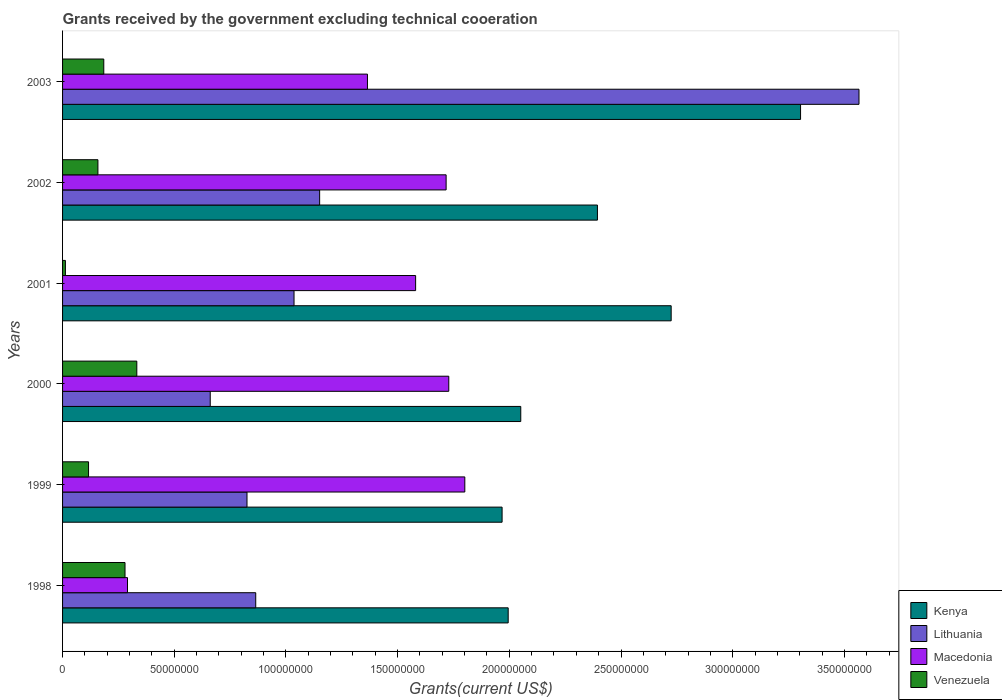How many groups of bars are there?
Provide a short and direct response. 6. Are the number of bars per tick equal to the number of legend labels?
Your response must be concise. Yes. Are the number of bars on each tick of the Y-axis equal?
Ensure brevity in your answer.  Yes. How many bars are there on the 3rd tick from the top?
Provide a succinct answer. 4. What is the total grants received by the government in Lithuania in 2002?
Give a very brief answer. 1.15e+08. Across all years, what is the maximum total grants received by the government in Macedonia?
Offer a very short reply. 1.80e+08. Across all years, what is the minimum total grants received by the government in Kenya?
Offer a terse response. 1.97e+08. In which year was the total grants received by the government in Venezuela minimum?
Offer a terse response. 2001. What is the total total grants received by the government in Macedonia in the graph?
Offer a very short reply. 8.48e+08. What is the difference between the total grants received by the government in Venezuela in 1999 and that in 2003?
Offer a terse response. -6.82e+06. What is the difference between the total grants received by the government in Venezuela in 2001 and the total grants received by the government in Lithuania in 2002?
Give a very brief answer. -1.14e+08. What is the average total grants received by the government in Macedonia per year?
Provide a short and direct response. 1.41e+08. In the year 2002, what is the difference between the total grants received by the government in Macedonia and total grants received by the government in Venezuela?
Provide a short and direct response. 1.56e+08. In how many years, is the total grants received by the government in Lithuania greater than 250000000 US$?
Your answer should be compact. 1. What is the ratio of the total grants received by the government in Macedonia in 1998 to that in 2001?
Your answer should be very brief. 0.18. Is the difference between the total grants received by the government in Macedonia in 2001 and 2003 greater than the difference between the total grants received by the government in Venezuela in 2001 and 2003?
Provide a short and direct response. Yes. What is the difference between the highest and the second highest total grants received by the government in Macedonia?
Provide a short and direct response. 7.18e+06. What is the difference between the highest and the lowest total grants received by the government in Lithuania?
Your answer should be very brief. 2.90e+08. In how many years, is the total grants received by the government in Macedonia greater than the average total grants received by the government in Macedonia taken over all years?
Keep it short and to the point. 4. What does the 2nd bar from the top in 2000 represents?
Ensure brevity in your answer.  Macedonia. What does the 3rd bar from the bottom in 1999 represents?
Ensure brevity in your answer.  Macedonia. Is it the case that in every year, the sum of the total grants received by the government in Lithuania and total grants received by the government in Kenya is greater than the total grants received by the government in Venezuela?
Ensure brevity in your answer.  Yes. How many bars are there?
Your answer should be compact. 24. What is the difference between two consecutive major ticks on the X-axis?
Keep it short and to the point. 5.00e+07. Where does the legend appear in the graph?
Give a very brief answer. Bottom right. How many legend labels are there?
Provide a short and direct response. 4. How are the legend labels stacked?
Provide a short and direct response. Vertical. What is the title of the graph?
Offer a terse response. Grants received by the government excluding technical cooeration. Does "East Asia (developing only)" appear as one of the legend labels in the graph?
Your response must be concise. No. What is the label or title of the X-axis?
Ensure brevity in your answer.  Grants(current US$). What is the Grants(current US$) in Kenya in 1998?
Offer a very short reply. 2.00e+08. What is the Grants(current US$) in Lithuania in 1998?
Offer a very short reply. 8.65e+07. What is the Grants(current US$) of Macedonia in 1998?
Give a very brief answer. 2.91e+07. What is the Grants(current US$) of Venezuela in 1998?
Offer a terse response. 2.80e+07. What is the Grants(current US$) of Kenya in 1999?
Your answer should be compact. 1.97e+08. What is the Grants(current US$) in Lithuania in 1999?
Your answer should be very brief. 8.26e+07. What is the Grants(current US$) of Macedonia in 1999?
Your answer should be compact. 1.80e+08. What is the Grants(current US$) in Venezuela in 1999?
Ensure brevity in your answer.  1.16e+07. What is the Grants(current US$) of Kenya in 2000?
Your answer should be very brief. 2.05e+08. What is the Grants(current US$) of Lithuania in 2000?
Your answer should be compact. 6.61e+07. What is the Grants(current US$) of Macedonia in 2000?
Your response must be concise. 1.73e+08. What is the Grants(current US$) of Venezuela in 2000?
Give a very brief answer. 3.32e+07. What is the Grants(current US$) in Kenya in 2001?
Ensure brevity in your answer.  2.72e+08. What is the Grants(current US$) in Lithuania in 2001?
Ensure brevity in your answer.  1.04e+08. What is the Grants(current US$) in Macedonia in 2001?
Your answer should be compact. 1.58e+08. What is the Grants(current US$) in Venezuela in 2001?
Provide a succinct answer. 1.27e+06. What is the Grants(current US$) in Kenya in 2002?
Ensure brevity in your answer.  2.39e+08. What is the Grants(current US$) of Lithuania in 2002?
Give a very brief answer. 1.15e+08. What is the Grants(current US$) in Macedonia in 2002?
Offer a terse response. 1.72e+08. What is the Grants(current US$) in Venezuela in 2002?
Give a very brief answer. 1.58e+07. What is the Grants(current US$) of Kenya in 2003?
Your response must be concise. 3.30e+08. What is the Grants(current US$) in Lithuania in 2003?
Your answer should be very brief. 3.57e+08. What is the Grants(current US$) in Macedonia in 2003?
Offer a very short reply. 1.36e+08. What is the Grants(current US$) in Venezuela in 2003?
Ensure brevity in your answer.  1.84e+07. Across all years, what is the maximum Grants(current US$) in Kenya?
Provide a short and direct response. 3.30e+08. Across all years, what is the maximum Grants(current US$) in Lithuania?
Your answer should be compact. 3.57e+08. Across all years, what is the maximum Grants(current US$) in Macedonia?
Your answer should be compact. 1.80e+08. Across all years, what is the maximum Grants(current US$) of Venezuela?
Your answer should be very brief. 3.32e+07. Across all years, what is the minimum Grants(current US$) in Kenya?
Your answer should be compact. 1.97e+08. Across all years, what is the minimum Grants(current US$) in Lithuania?
Your answer should be compact. 6.61e+07. Across all years, what is the minimum Grants(current US$) in Macedonia?
Provide a succinct answer. 2.91e+07. Across all years, what is the minimum Grants(current US$) of Venezuela?
Offer a very short reply. 1.27e+06. What is the total Grants(current US$) in Kenya in the graph?
Make the answer very short. 1.44e+09. What is the total Grants(current US$) in Lithuania in the graph?
Offer a terse response. 8.10e+08. What is the total Grants(current US$) of Macedonia in the graph?
Ensure brevity in your answer.  8.48e+08. What is the total Grants(current US$) of Venezuela in the graph?
Offer a terse response. 1.08e+08. What is the difference between the Grants(current US$) of Kenya in 1998 and that in 1999?
Provide a succinct answer. 2.73e+06. What is the difference between the Grants(current US$) of Lithuania in 1998 and that in 1999?
Offer a very short reply. 3.91e+06. What is the difference between the Grants(current US$) of Macedonia in 1998 and that in 1999?
Your answer should be very brief. -1.51e+08. What is the difference between the Grants(current US$) of Venezuela in 1998 and that in 1999?
Your answer should be very brief. 1.63e+07. What is the difference between the Grants(current US$) of Kenya in 1998 and that in 2000?
Ensure brevity in your answer.  -5.63e+06. What is the difference between the Grants(current US$) in Lithuania in 1998 and that in 2000?
Your answer should be very brief. 2.04e+07. What is the difference between the Grants(current US$) of Macedonia in 1998 and that in 2000?
Give a very brief answer. -1.44e+08. What is the difference between the Grants(current US$) of Venezuela in 1998 and that in 2000?
Make the answer very short. -5.28e+06. What is the difference between the Grants(current US$) in Kenya in 1998 and that in 2001?
Your response must be concise. -7.30e+07. What is the difference between the Grants(current US$) in Lithuania in 1998 and that in 2001?
Provide a succinct answer. -1.71e+07. What is the difference between the Grants(current US$) in Macedonia in 1998 and that in 2001?
Your answer should be compact. -1.29e+08. What is the difference between the Grants(current US$) in Venezuela in 1998 and that in 2001?
Your answer should be very brief. 2.67e+07. What is the difference between the Grants(current US$) of Kenya in 1998 and that in 2002?
Your answer should be compact. -4.00e+07. What is the difference between the Grants(current US$) in Lithuania in 1998 and that in 2002?
Ensure brevity in your answer.  -2.86e+07. What is the difference between the Grants(current US$) of Macedonia in 1998 and that in 2002?
Keep it short and to the point. -1.43e+08. What is the difference between the Grants(current US$) of Venezuela in 1998 and that in 2002?
Ensure brevity in your answer.  1.21e+07. What is the difference between the Grants(current US$) in Kenya in 1998 and that in 2003?
Your answer should be very brief. -1.31e+08. What is the difference between the Grants(current US$) in Lithuania in 1998 and that in 2003?
Provide a succinct answer. -2.70e+08. What is the difference between the Grants(current US$) in Macedonia in 1998 and that in 2003?
Make the answer very short. -1.07e+08. What is the difference between the Grants(current US$) in Venezuela in 1998 and that in 2003?
Your response must be concise. 9.51e+06. What is the difference between the Grants(current US$) in Kenya in 1999 and that in 2000?
Keep it short and to the point. -8.36e+06. What is the difference between the Grants(current US$) of Lithuania in 1999 and that in 2000?
Keep it short and to the point. 1.65e+07. What is the difference between the Grants(current US$) in Macedonia in 1999 and that in 2000?
Offer a very short reply. 7.18e+06. What is the difference between the Grants(current US$) of Venezuela in 1999 and that in 2000?
Ensure brevity in your answer.  -2.16e+07. What is the difference between the Grants(current US$) of Kenya in 1999 and that in 2001?
Provide a short and direct response. -7.57e+07. What is the difference between the Grants(current US$) of Lithuania in 1999 and that in 2001?
Your answer should be very brief. -2.10e+07. What is the difference between the Grants(current US$) in Macedonia in 1999 and that in 2001?
Ensure brevity in your answer.  2.20e+07. What is the difference between the Grants(current US$) of Venezuela in 1999 and that in 2001?
Keep it short and to the point. 1.04e+07. What is the difference between the Grants(current US$) in Kenya in 1999 and that in 2002?
Provide a short and direct response. -4.27e+07. What is the difference between the Grants(current US$) in Lithuania in 1999 and that in 2002?
Offer a very short reply. -3.25e+07. What is the difference between the Grants(current US$) of Macedonia in 1999 and that in 2002?
Offer a very short reply. 8.37e+06. What is the difference between the Grants(current US$) in Venezuela in 1999 and that in 2002?
Give a very brief answer. -4.20e+06. What is the difference between the Grants(current US$) in Kenya in 1999 and that in 2003?
Give a very brief answer. -1.34e+08. What is the difference between the Grants(current US$) of Lithuania in 1999 and that in 2003?
Ensure brevity in your answer.  -2.74e+08. What is the difference between the Grants(current US$) in Macedonia in 1999 and that in 2003?
Provide a short and direct response. 4.36e+07. What is the difference between the Grants(current US$) in Venezuela in 1999 and that in 2003?
Make the answer very short. -6.82e+06. What is the difference between the Grants(current US$) in Kenya in 2000 and that in 2001?
Make the answer very short. -6.73e+07. What is the difference between the Grants(current US$) of Lithuania in 2000 and that in 2001?
Keep it short and to the point. -3.75e+07. What is the difference between the Grants(current US$) in Macedonia in 2000 and that in 2001?
Your answer should be compact. 1.48e+07. What is the difference between the Grants(current US$) in Venezuela in 2000 and that in 2001?
Ensure brevity in your answer.  3.20e+07. What is the difference between the Grants(current US$) of Kenya in 2000 and that in 2002?
Your response must be concise. -3.43e+07. What is the difference between the Grants(current US$) of Lithuania in 2000 and that in 2002?
Your answer should be compact. -4.90e+07. What is the difference between the Grants(current US$) in Macedonia in 2000 and that in 2002?
Give a very brief answer. 1.19e+06. What is the difference between the Grants(current US$) of Venezuela in 2000 and that in 2002?
Ensure brevity in your answer.  1.74e+07. What is the difference between the Grants(current US$) in Kenya in 2000 and that in 2003?
Provide a short and direct response. -1.25e+08. What is the difference between the Grants(current US$) of Lithuania in 2000 and that in 2003?
Your answer should be very brief. -2.90e+08. What is the difference between the Grants(current US$) of Macedonia in 2000 and that in 2003?
Give a very brief answer. 3.64e+07. What is the difference between the Grants(current US$) of Venezuela in 2000 and that in 2003?
Ensure brevity in your answer.  1.48e+07. What is the difference between the Grants(current US$) in Kenya in 2001 and that in 2002?
Offer a terse response. 3.30e+07. What is the difference between the Grants(current US$) of Lithuania in 2001 and that in 2002?
Offer a terse response. -1.15e+07. What is the difference between the Grants(current US$) in Macedonia in 2001 and that in 2002?
Offer a terse response. -1.36e+07. What is the difference between the Grants(current US$) in Venezuela in 2001 and that in 2002?
Your response must be concise. -1.46e+07. What is the difference between the Grants(current US$) in Kenya in 2001 and that in 2003?
Make the answer very short. -5.79e+07. What is the difference between the Grants(current US$) of Lithuania in 2001 and that in 2003?
Offer a terse response. -2.53e+08. What is the difference between the Grants(current US$) in Macedonia in 2001 and that in 2003?
Your answer should be compact. 2.16e+07. What is the difference between the Grants(current US$) in Venezuela in 2001 and that in 2003?
Provide a succinct answer. -1.72e+07. What is the difference between the Grants(current US$) of Kenya in 2002 and that in 2003?
Your answer should be very brief. -9.09e+07. What is the difference between the Grants(current US$) in Lithuania in 2002 and that in 2003?
Provide a short and direct response. -2.41e+08. What is the difference between the Grants(current US$) in Macedonia in 2002 and that in 2003?
Give a very brief answer. 3.52e+07. What is the difference between the Grants(current US$) in Venezuela in 2002 and that in 2003?
Provide a short and direct response. -2.62e+06. What is the difference between the Grants(current US$) of Kenya in 1998 and the Grants(current US$) of Lithuania in 1999?
Your answer should be compact. 1.17e+08. What is the difference between the Grants(current US$) of Kenya in 1998 and the Grants(current US$) of Macedonia in 1999?
Ensure brevity in your answer.  1.94e+07. What is the difference between the Grants(current US$) of Kenya in 1998 and the Grants(current US$) of Venezuela in 1999?
Your answer should be compact. 1.88e+08. What is the difference between the Grants(current US$) in Lithuania in 1998 and the Grants(current US$) in Macedonia in 1999?
Your answer should be compact. -9.36e+07. What is the difference between the Grants(current US$) of Lithuania in 1998 and the Grants(current US$) of Venezuela in 1999?
Your response must be concise. 7.48e+07. What is the difference between the Grants(current US$) in Macedonia in 1998 and the Grants(current US$) in Venezuela in 1999?
Ensure brevity in your answer.  1.74e+07. What is the difference between the Grants(current US$) of Kenya in 1998 and the Grants(current US$) of Lithuania in 2000?
Your response must be concise. 1.33e+08. What is the difference between the Grants(current US$) of Kenya in 1998 and the Grants(current US$) of Macedonia in 2000?
Give a very brief answer. 2.66e+07. What is the difference between the Grants(current US$) in Kenya in 1998 and the Grants(current US$) in Venezuela in 2000?
Provide a succinct answer. 1.66e+08. What is the difference between the Grants(current US$) in Lithuania in 1998 and the Grants(current US$) in Macedonia in 2000?
Ensure brevity in your answer.  -8.64e+07. What is the difference between the Grants(current US$) in Lithuania in 1998 and the Grants(current US$) in Venezuela in 2000?
Your answer should be compact. 5.32e+07. What is the difference between the Grants(current US$) in Macedonia in 1998 and the Grants(current US$) in Venezuela in 2000?
Your response must be concise. -4.17e+06. What is the difference between the Grants(current US$) in Kenya in 1998 and the Grants(current US$) in Lithuania in 2001?
Offer a terse response. 9.59e+07. What is the difference between the Grants(current US$) in Kenya in 1998 and the Grants(current US$) in Macedonia in 2001?
Provide a short and direct response. 4.14e+07. What is the difference between the Grants(current US$) of Kenya in 1998 and the Grants(current US$) of Venezuela in 2001?
Keep it short and to the point. 1.98e+08. What is the difference between the Grants(current US$) of Lithuania in 1998 and the Grants(current US$) of Macedonia in 2001?
Your response must be concise. -7.16e+07. What is the difference between the Grants(current US$) in Lithuania in 1998 and the Grants(current US$) in Venezuela in 2001?
Give a very brief answer. 8.52e+07. What is the difference between the Grants(current US$) of Macedonia in 1998 and the Grants(current US$) of Venezuela in 2001?
Ensure brevity in your answer.  2.78e+07. What is the difference between the Grants(current US$) of Kenya in 1998 and the Grants(current US$) of Lithuania in 2002?
Your answer should be very brief. 8.44e+07. What is the difference between the Grants(current US$) of Kenya in 1998 and the Grants(current US$) of Macedonia in 2002?
Give a very brief answer. 2.78e+07. What is the difference between the Grants(current US$) of Kenya in 1998 and the Grants(current US$) of Venezuela in 2002?
Provide a succinct answer. 1.84e+08. What is the difference between the Grants(current US$) in Lithuania in 1998 and the Grants(current US$) in Macedonia in 2002?
Your answer should be very brief. -8.52e+07. What is the difference between the Grants(current US$) of Lithuania in 1998 and the Grants(current US$) of Venezuela in 2002?
Provide a succinct answer. 7.06e+07. What is the difference between the Grants(current US$) in Macedonia in 1998 and the Grants(current US$) in Venezuela in 2002?
Provide a short and direct response. 1.32e+07. What is the difference between the Grants(current US$) of Kenya in 1998 and the Grants(current US$) of Lithuania in 2003?
Ensure brevity in your answer.  -1.57e+08. What is the difference between the Grants(current US$) in Kenya in 1998 and the Grants(current US$) in Macedonia in 2003?
Your response must be concise. 6.30e+07. What is the difference between the Grants(current US$) in Kenya in 1998 and the Grants(current US$) in Venezuela in 2003?
Provide a short and direct response. 1.81e+08. What is the difference between the Grants(current US$) of Lithuania in 1998 and the Grants(current US$) of Macedonia in 2003?
Offer a terse response. -5.00e+07. What is the difference between the Grants(current US$) in Lithuania in 1998 and the Grants(current US$) in Venezuela in 2003?
Offer a terse response. 6.80e+07. What is the difference between the Grants(current US$) of Macedonia in 1998 and the Grants(current US$) of Venezuela in 2003?
Keep it short and to the point. 1.06e+07. What is the difference between the Grants(current US$) in Kenya in 1999 and the Grants(current US$) in Lithuania in 2000?
Your answer should be very brief. 1.31e+08. What is the difference between the Grants(current US$) of Kenya in 1999 and the Grants(current US$) of Macedonia in 2000?
Your response must be concise. 2.39e+07. What is the difference between the Grants(current US$) of Kenya in 1999 and the Grants(current US$) of Venezuela in 2000?
Give a very brief answer. 1.64e+08. What is the difference between the Grants(current US$) in Lithuania in 1999 and the Grants(current US$) in Macedonia in 2000?
Make the answer very short. -9.03e+07. What is the difference between the Grants(current US$) in Lithuania in 1999 and the Grants(current US$) in Venezuela in 2000?
Keep it short and to the point. 4.93e+07. What is the difference between the Grants(current US$) of Macedonia in 1999 and the Grants(current US$) of Venezuela in 2000?
Offer a very short reply. 1.47e+08. What is the difference between the Grants(current US$) in Kenya in 1999 and the Grants(current US$) in Lithuania in 2001?
Make the answer very short. 9.32e+07. What is the difference between the Grants(current US$) in Kenya in 1999 and the Grants(current US$) in Macedonia in 2001?
Your answer should be very brief. 3.87e+07. What is the difference between the Grants(current US$) in Kenya in 1999 and the Grants(current US$) in Venezuela in 2001?
Your response must be concise. 1.96e+08. What is the difference between the Grants(current US$) in Lithuania in 1999 and the Grants(current US$) in Macedonia in 2001?
Your answer should be compact. -7.55e+07. What is the difference between the Grants(current US$) in Lithuania in 1999 and the Grants(current US$) in Venezuela in 2001?
Ensure brevity in your answer.  8.13e+07. What is the difference between the Grants(current US$) in Macedonia in 1999 and the Grants(current US$) in Venezuela in 2001?
Provide a short and direct response. 1.79e+08. What is the difference between the Grants(current US$) of Kenya in 1999 and the Grants(current US$) of Lithuania in 2002?
Offer a very short reply. 8.17e+07. What is the difference between the Grants(current US$) in Kenya in 1999 and the Grants(current US$) in Macedonia in 2002?
Make the answer very short. 2.51e+07. What is the difference between the Grants(current US$) of Kenya in 1999 and the Grants(current US$) of Venezuela in 2002?
Provide a short and direct response. 1.81e+08. What is the difference between the Grants(current US$) in Lithuania in 1999 and the Grants(current US$) in Macedonia in 2002?
Offer a terse response. -8.91e+07. What is the difference between the Grants(current US$) in Lithuania in 1999 and the Grants(current US$) in Venezuela in 2002?
Your answer should be compact. 6.67e+07. What is the difference between the Grants(current US$) of Macedonia in 1999 and the Grants(current US$) of Venezuela in 2002?
Keep it short and to the point. 1.64e+08. What is the difference between the Grants(current US$) in Kenya in 1999 and the Grants(current US$) in Lithuania in 2003?
Provide a succinct answer. -1.60e+08. What is the difference between the Grants(current US$) of Kenya in 1999 and the Grants(current US$) of Macedonia in 2003?
Keep it short and to the point. 6.03e+07. What is the difference between the Grants(current US$) of Kenya in 1999 and the Grants(current US$) of Venezuela in 2003?
Your response must be concise. 1.78e+08. What is the difference between the Grants(current US$) in Lithuania in 1999 and the Grants(current US$) in Macedonia in 2003?
Your answer should be compact. -5.39e+07. What is the difference between the Grants(current US$) in Lithuania in 1999 and the Grants(current US$) in Venezuela in 2003?
Your answer should be very brief. 6.41e+07. What is the difference between the Grants(current US$) in Macedonia in 1999 and the Grants(current US$) in Venezuela in 2003?
Your answer should be compact. 1.62e+08. What is the difference between the Grants(current US$) of Kenya in 2000 and the Grants(current US$) of Lithuania in 2001?
Your answer should be compact. 1.02e+08. What is the difference between the Grants(current US$) of Kenya in 2000 and the Grants(current US$) of Macedonia in 2001?
Provide a succinct answer. 4.71e+07. What is the difference between the Grants(current US$) in Kenya in 2000 and the Grants(current US$) in Venezuela in 2001?
Your answer should be very brief. 2.04e+08. What is the difference between the Grants(current US$) of Lithuania in 2000 and the Grants(current US$) of Macedonia in 2001?
Your answer should be compact. -9.20e+07. What is the difference between the Grants(current US$) in Lithuania in 2000 and the Grants(current US$) in Venezuela in 2001?
Your answer should be very brief. 6.48e+07. What is the difference between the Grants(current US$) of Macedonia in 2000 and the Grants(current US$) of Venezuela in 2001?
Make the answer very short. 1.72e+08. What is the difference between the Grants(current US$) in Kenya in 2000 and the Grants(current US$) in Lithuania in 2002?
Your answer should be very brief. 9.00e+07. What is the difference between the Grants(current US$) of Kenya in 2000 and the Grants(current US$) of Macedonia in 2002?
Offer a very short reply. 3.34e+07. What is the difference between the Grants(current US$) in Kenya in 2000 and the Grants(current US$) in Venezuela in 2002?
Provide a short and direct response. 1.89e+08. What is the difference between the Grants(current US$) of Lithuania in 2000 and the Grants(current US$) of Macedonia in 2002?
Your answer should be compact. -1.06e+08. What is the difference between the Grants(current US$) of Lithuania in 2000 and the Grants(current US$) of Venezuela in 2002?
Provide a short and direct response. 5.03e+07. What is the difference between the Grants(current US$) of Macedonia in 2000 and the Grants(current US$) of Venezuela in 2002?
Provide a short and direct response. 1.57e+08. What is the difference between the Grants(current US$) in Kenya in 2000 and the Grants(current US$) in Lithuania in 2003?
Your answer should be compact. -1.51e+08. What is the difference between the Grants(current US$) of Kenya in 2000 and the Grants(current US$) of Macedonia in 2003?
Provide a succinct answer. 6.86e+07. What is the difference between the Grants(current US$) of Kenya in 2000 and the Grants(current US$) of Venezuela in 2003?
Your response must be concise. 1.87e+08. What is the difference between the Grants(current US$) in Lithuania in 2000 and the Grants(current US$) in Macedonia in 2003?
Make the answer very short. -7.04e+07. What is the difference between the Grants(current US$) in Lithuania in 2000 and the Grants(current US$) in Venezuela in 2003?
Provide a short and direct response. 4.77e+07. What is the difference between the Grants(current US$) of Macedonia in 2000 and the Grants(current US$) of Venezuela in 2003?
Offer a terse response. 1.54e+08. What is the difference between the Grants(current US$) of Kenya in 2001 and the Grants(current US$) of Lithuania in 2002?
Your answer should be very brief. 1.57e+08. What is the difference between the Grants(current US$) of Kenya in 2001 and the Grants(current US$) of Macedonia in 2002?
Keep it short and to the point. 1.01e+08. What is the difference between the Grants(current US$) in Kenya in 2001 and the Grants(current US$) in Venezuela in 2002?
Provide a succinct answer. 2.57e+08. What is the difference between the Grants(current US$) of Lithuania in 2001 and the Grants(current US$) of Macedonia in 2002?
Your answer should be very brief. -6.81e+07. What is the difference between the Grants(current US$) of Lithuania in 2001 and the Grants(current US$) of Venezuela in 2002?
Ensure brevity in your answer.  8.78e+07. What is the difference between the Grants(current US$) in Macedonia in 2001 and the Grants(current US$) in Venezuela in 2002?
Provide a succinct answer. 1.42e+08. What is the difference between the Grants(current US$) in Kenya in 2001 and the Grants(current US$) in Lithuania in 2003?
Your response must be concise. -8.41e+07. What is the difference between the Grants(current US$) of Kenya in 2001 and the Grants(current US$) of Macedonia in 2003?
Your response must be concise. 1.36e+08. What is the difference between the Grants(current US$) of Kenya in 2001 and the Grants(current US$) of Venezuela in 2003?
Your response must be concise. 2.54e+08. What is the difference between the Grants(current US$) in Lithuania in 2001 and the Grants(current US$) in Macedonia in 2003?
Keep it short and to the point. -3.29e+07. What is the difference between the Grants(current US$) in Lithuania in 2001 and the Grants(current US$) in Venezuela in 2003?
Offer a terse response. 8.52e+07. What is the difference between the Grants(current US$) of Macedonia in 2001 and the Grants(current US$) of Venezuela in 2003?
Your answer should be very brief. 1.40e+08. What is the difference between the Grants(current US$) of Kenya in 2002 and the Grants(current US$) of Lithuania in 2003?
Give a very brief answer. -1.17e+08. What is the difference between the Grants(current US$) of Kenya in 2002 and the Grants(current US$) of Macedonia in 2003?
Your answer should be very brief. 1.03e+08. What is the difference between the Grants(current US$) in Kenya in 2002 and the Grants(current US$) in Venezuela in 2003?
Provide a succinct answer. 2.21e+08. What is the difference between the Grants(current US$) in Lithuania in 2002 and the Grants(current US$) in Macedonia in 2003?
Ensure brevity in your answer.  -2.14e+07. What is the difference between the Grants(current US$) in Lithuania in 2002 and the Grants(current US$) in Venezuela in 2003?
Provide a short and direct response. 9.66e+07. What is the difference between the Grants(current US$) in Macedonia in 2002 and the Grants(current US$) in Venezuela in 2003?
Provide a short and direct response. 1.53e+08. What is the average Grants(current US$) in Kenya per year?
Ensure brevity in your answer.  2.41e+08. What is the average Grants(current US$) of Lithuania per year?
Your response must be concise. 1.35e+08. What is the average Grants(current US$) in Macedonia per year?
Your response must be concise. 1.41e+08. What is the average Grants(current US$) in Venezuela per year?
Your answer should be compact. 1.81e+07. In the year 1998, what is the difference between the Grants(current US$) in Kenya and Grants(current US$) in Lithuania?
Offer a terse response. 1.13e+08. In the year 1998, what is the difference between the Grants(current US$) in Kenya and Grants(current US$) in Macedonia?
Offer a very short reply. 1.70e+08. In the year 1998, what is the difference between the Grants(current US$) of Kenya and Grants(current US$) of Venezuela?
Your answer should be very brief. 1.72e+08. In the year 1998, what is the difference between the Grants(current US$) of Lithuania and Grants(current US$) of Macedonia?
Ensure brevity in your answer.  5.74e+07. In the year 1998, what is the difference between the Grants(current US$) in Lithuania and Grants(current US$) in Venezuela?
Make the answer very short. 5.85e+07. In the year 1998, what is the difference between the Grants(current US$) in Macedonia and Grants(current US$) in Venezuela?
Your response must be concise. 1.11e+06. In the year 1999, what is the difference between the Grants(current US$) in Kenya and Grants(current US$) in Lithuania?
Ensure brevity in your answer.  1.14e+08. In the year 1999, what is the difference between the Grants(current US$) of Kenya and Grants(current US$) of Macedonia?
Offer a terse response. 1.67e+07. In the year 1999, what is the difference between the Grants(current US$) of Kenya and Grants(current US$) of Venezuela?
Your response must be concise. 1.85e+08. In the year 1999, what is the difference between the Grants(current US$) of Lithuania and Grants(current US$) of Macedonia?
Your answer should be compact. -9.75e+07. In the year 1999, what is the difference between the Grants(current US$) of Lithuania and Grants(current US$) of Venezuela?
Make the answer very short. 7.09e+07. In the year 1999, what is the difference between the Grants(current US$) in Macedonia and Grants(current US$) in Venezuela?
Your response must be concise. 1.68e+08. In the year 2000, what is the difference between the Grants(current US$) in Kenya and Grants(current US$) in Lithuania?
Provide a succinct answer. 1.39e+08. In the year 2000, what is the difference between the Grants(current US$) in Kenya and Grants(current US$) in Macedonia?
Your answer should be very brief. 3.22e+07. In the year 2000, what is the difference between the Grants(current US$) of Kenya and Grants(current US$) of Venezuela?
Give a very brief answer. 1.72e+08. In the year 2000, what is the difference between the Grants(current US$) in Lithuania and Grants(current US$) in Macedonia?
Ensure brevity in your answer.  -1.07e+08. In the year 2000, what is the difference between the Grants(current US$) of Lithuania and Grants(current US$) of Venezuela?
Provide a succinct answer. 3.29e+07. In the year 2000, what is the difference between the Grants(current US$) of Macedonia and Grants(current US$) of Venezuela?
Make the answer very short. 1.40e+08. In the year 2001, what is the difference between the Grants(current US$) of Kenya and Grants(current US$) of Lithuania?
Make the answer very short. 1.69e+08. In the year 2001, what is the difference between the Grants(current US$) in Kenya and Grants(current US$) in Macedonia?
Offer a terse response. 1.14e+08. In the year 2001, what is the difference between the Grants(current US$) in Kenya and Grants(current US$) in Venezuela?
Your answer should be very brief. 2.71e+08. In the year 2001, what is the difference between the Grants(current US$) in Lithuania and Grants(current US$) in Macedonia?
Offer a very short reply. -5.44e+07. In the year 2001, what is the difference between the Grants(current US$) in Lithuania and Grants(current US$) in Venezuela?
Ensure brevity in your answer.  1.02e+08. In the year 2001, what is the difference between the Grants(current US$) in Macedonia and Grants(current US$) in Venezuela?
Ensure brevity in your answer.  1.57e+08. In the year 2002, what is the difference between the Grants(current US$) of Kenya and Grants(current US$) of Lithuania?
Provide a succinct answer. 1.24e+08. In the year 2002, what is the difference between the Grants(current US$) in Kenya and Grants(current US$) in Macedonia?
Your answer should be compact. 6.77e+07. In the year 2002, what is the difference between the Grants(current US$) in Kenya and Grants(current US$) in Venezuela?
Ensure brevity in your answer.  2.24e+08. In the year 2002, what is the difference between the Grants(current US$) in Lithuania and Grants(current US$) in Macedonia?
Offer a very short reply. -5.66e+07. In the year 2002, what is the difference between the Grants(current US$) of Lithuania and Grants(current US$) of Venezuela?
Ensure brevity in your answer.  9.93e+07. In the year 2002, what is the difference between the Grants(current US$) in Macedonia and Grants(current US$) in Venezuela?
Your answer should be compact. 1.56e+08. In the year 2003, what is the difference between the Grants(current US$) of Kenya and Grants(current US$) of Lithuania?
Give a very brief answer. -2.62e+07. In the year 2003, what is the difference between the Grants(current US$) of Kenya and Grants(current US$) of Macedonia?
Ensure brevity in your answer.  1.94e+08. In the year 2003, what is the difference between the Grants(current US$) in Kenya and Grants(current US$) in Venezuela?
Your answer should be very brief. 3.12e+08. In the year 2003, what is the difference between the Grants(current US$) of Lithuania and Grants(current US$) of Macedonia?
Make the answer very short. 2.20e+08. In the year 2003, what is the difference between the Grants(current US$) in Lithuania and Grants(current US$) in Venezuela?
Ensure brevity in your answer.  3.38e+08. In the year 2003, what is the difference between the Grants(current US$) of Macedonia and Grants(current US$) of Venezuela?
Offer a terse response. 1.18e+08. What is the ratio of the Grants(current US$) of Kenya in 1998 to that in 1999?
Make the answer very short. 1.01. What is the ratio of the Grants(current US$) in Lithuania in 1998 to that in 1999?
Provide a succinct answer. 1.05. What is the ratio of the Grants(current US$) of Macedonia in 1998 to that in 1999?
Keep it short and to the point. 0.16. What is the ratio of the Grants(current US$) of Venezuela in 1998 to that in 1999?
Offer a terse response. 2.4. What is the ratio of the Grants(current US$) of Kenya in 1998 to that in 2000?
Keep it short and to the point. 0.97. What is the ratio of the Grants(current US$) of Lithuania in 1998 to that in 2000?
Your answer should be compact. 1.31. What is the ratio of the Grants(current US$) in Macedonia in 1998 to that in 2000?
Offer a terse response. 0.17. What is the ratio of the Grants(current US$) in Venezuela in 1998 to that in 2000?
Offer a terse response. 0.84. What is the ratio of the Grants(current US$) in Kenya in 1998 to that in 2001?
Ensure brevity in your answer.  0.73. What is the ratio of the Grants(current US$) in Lithuania in 1998 to that in 2001?
Give a very brief answer. 0.83. What is the ratio of the Grants(current US$) in Macedonia in 1998 to that in 2001?
Offer a terse response. 0.18. What is the ratio of the Grants(current US$) of Venezuela in 1998 to that in 2001?
Keep it short and to the point. 22.02. What is the ratio of the Grants(current US$) in Kenya in 1998 to that in 2002?
Ensure brevity in your answer.  0.83. What is the ratio of the Grants(current US$) of Lithuania in 1998 to that in 2002?
Your answer should be compact. 0.75. What is the ratio of the Grants(current US$) of Macedonia in 1998 to that in 2002?
Give a very brief answer. 0.17. What is the ratio of the Grants(current US$) in Venezuela in 1998 to that in 2002?
Provide a succinct answer. 1.77. What is the ratio of the Grants(current US$) of Kenya in 1998 to that in 2003?
Provide a succinct answer. 0.6. What is the ratio of the Grants(current US$) in Lithuania in 1998 to that in 2003?
Keep it short and to the point. 0.24. What is the ratio of the Grants(current US$) of Macedonia in 1998 to that in 2003?
Make the answer very short. 0.21. What is the ratio of the Grants(current US$) in Venezuela in 1998 to that in 2003?
Ensure brevity in your answer.  1.52. What is the ratio of the Grants(current US$) of Kenya in 1999 to that in 2000?
Your response must be concise. 0.96. What is the ratio of the Grants(current US$) of Lithuania in 1999 to that in 2000?
Provide a short and direct response. 1.25. What is the ratio of the Grants(current US$) of Macedonia in 1999 to that in 2000?
Provide a short and direct response. 1.04. What is the ratio of the Grants(current US$) of Venezuela in 1999 to that in 2000?
Keep it short and to the point. 0.35. What is the ratio of the Grants(current US$) in Kenya in 1999 to that in 2001?
Offer a terse response. 0.72. What is the ratio of the Grants(current US$) of Lithuania in 1999 to that in 2001?
Ensure brevity in your answer.  0.8. What is the ratio of the Grants(current US$) of Macedonia in 1999 to that in 2001?
Ensure brevity in your answer.  1.14. What is the ratio of the Grants(current US$) of Venezuela in 1999 to that in 2001?
Provide a short and direct response. 9.16. What is the ratio of the Grants(current US$) of Kenya in 1999 to that in 2002?
Your answer should be very brief. 0.82. What is the ratio of the Grants(current US$) in Lithuania in 1999 to that in 2002?
Your response must be concise. 0.72. What is the ratio of the Grants(current US$) in Macedonia in 1999 to that in 2002?
Ensure brevity in your answer.  1.05. What is the ratio of the Grants(current US$) of Venezuela in 1999 to that in 2002?
Your answer should be very brief. 0.73. What is the ratio of the Grants(current US$) of Kenya in 1999 to that in 2003?
Offer a very short reply. 0.6. What is the ratio of the Grants(current US$) in Lithuania in 1999 to that in 2003?
Provide a short and direct response. 0.23. What is the ratio of the Grants(current US$) of Macedonia in 1999 to that in 2003?
Offer a terse response. 1.32. What is the ratio of the Grants(current US$) of Venezuela in 1999 to that in 2003?
Offer a terse response. 0.63. What is the ratio of the Grants(current US$) of Kenya in 2000 to that in 2001?
Ensure brevity in your answer.  0.75. What is the ratio of the Grants(current US$) in Lithuania in 2000 to that in 2001?
Your answer should be very brief. 0.64. What is the ratio of the Grants(current US$) of Macedonia in 2000 to that in 2001?
Ensure brevity in your answer.  1.09. What is the ratio of the Grants(current US$) in Venezuela in 2000 to that in 2001?
Ensure brevity in your answer.  26.17. What is the ratio of the Grants(current US$) of Kenya in 2000 to that in 2002?
Make the answer very short. 0.86. What is the ratio of the Grants(current US$) of Lithuania in 2000 to that in 2002?
Offer a very short reply. 0.57. What is the ratio of the Grants(current US$) of Macedonia in 2000 to that in 2002?
Your answer should be very brief. 1.01. What is the ratio of the Grants(current US$) of Venezuela in 2000 to that in 2002?
Offer a terse response. 2.1. What is the ratio of the Grants(current US$) of Kenya in 2000 to that in 2003?
Your answer should be very brief. 0.62. What is the ratio of the Grants(current US$) of Lithuania in 2000 to that in 2003?
Ensure brevity in your answer.  0.19. What is the ratio of the Grants(current US$) of Macedonia in 2000 to that in 2003?
Your answer should be compact. 1.27. What is the ratio of the Grants(current US$) of Venezuela in 2000 to that in 2003?
Offer a very short reply. 1.8. What is the ratio of the Grants(current US$) in Kenya in 2001 to that in 2002?
Give a very brief answer. 1.14. What is the ratio of the Grants(current US$) in Lithuania in 2001 to that in 2002?
Keep it short and to the point. 0.9. What is the ratio of the Grants(current US$) of Macedonia in 2001 to that in 2002?
Make the answer very short. 0.92. What is the ratio of the Grants(current US$) of Venezuela in 2001 to that in 2002?
Give a very brief answer. 0.08. What is the ratio of the Grants(current US$) in Kenya in 2001 to that in 2003?
Ensure brevity in your answer.  0.82. What is the ratio of the Grants(current US$) in Lithuania in 2001 to that in 2003?
Your answer should be very brief. 0.29. What is the ratio of the Grants(current US$) of Macedonia in 2001 to that in 2003?
Keep it short and to the point. 1.16. What is the ratio of the Grants(current US$) in Venezuela in 2001 to that in 2003?
Offer a very short reply. 0.07. What is the ratio of the Grants(current US$) of Kenya in 2002 to that in 2003?
Provide a short and direct response. 0.72. What is the ratio of the Grants(current US$) in Lithuania in 2002 to that in 2003?
Offer a very short reply. 0.32. What is the ratio of the Grants(current US$) in Macedonia in 2002 to that in 2003?
Provide a short and direct response. 1.26. What is the ratio of the Grants(current US$) of Venezuela in 2002 to that in 2003?
Offer a very short reply. 0.86. What is the difference between the highest and the second highest Grants(current US$) in Kenya?
Ensure brevity in your answer.  5.79e+07. What is the difference between the highest and the second highest Grants(current US$) in Lithuania?
Your answer should be very brief. 2.41e+08. What is the difference between the highest and the second highest Grants(current US$) in Macedonia?
Keep it short and to the point. 7.18e+06. What is the difference between the highest and the second highest Grants(current US$) in Venezuela?
Offer a terse response. 5.28e+06. What is the difference between the highest and the lowest Grants(current US$) in Kenya?
Your answer should be very brief. 1.34e+08. What is the difference between the highest and the lowest Grants(current US$) in Lithuania?
Make the answer very short. 2.90e+08. What is the difference between the highest and the lowest Grants(current US$) in Macedonia?
Make the answer very short. 1.51e+08. What is the difference between the highest and the lowest Grants(current US$) of Venezuela?
Provide a succinct answer. 3.20e+07. 